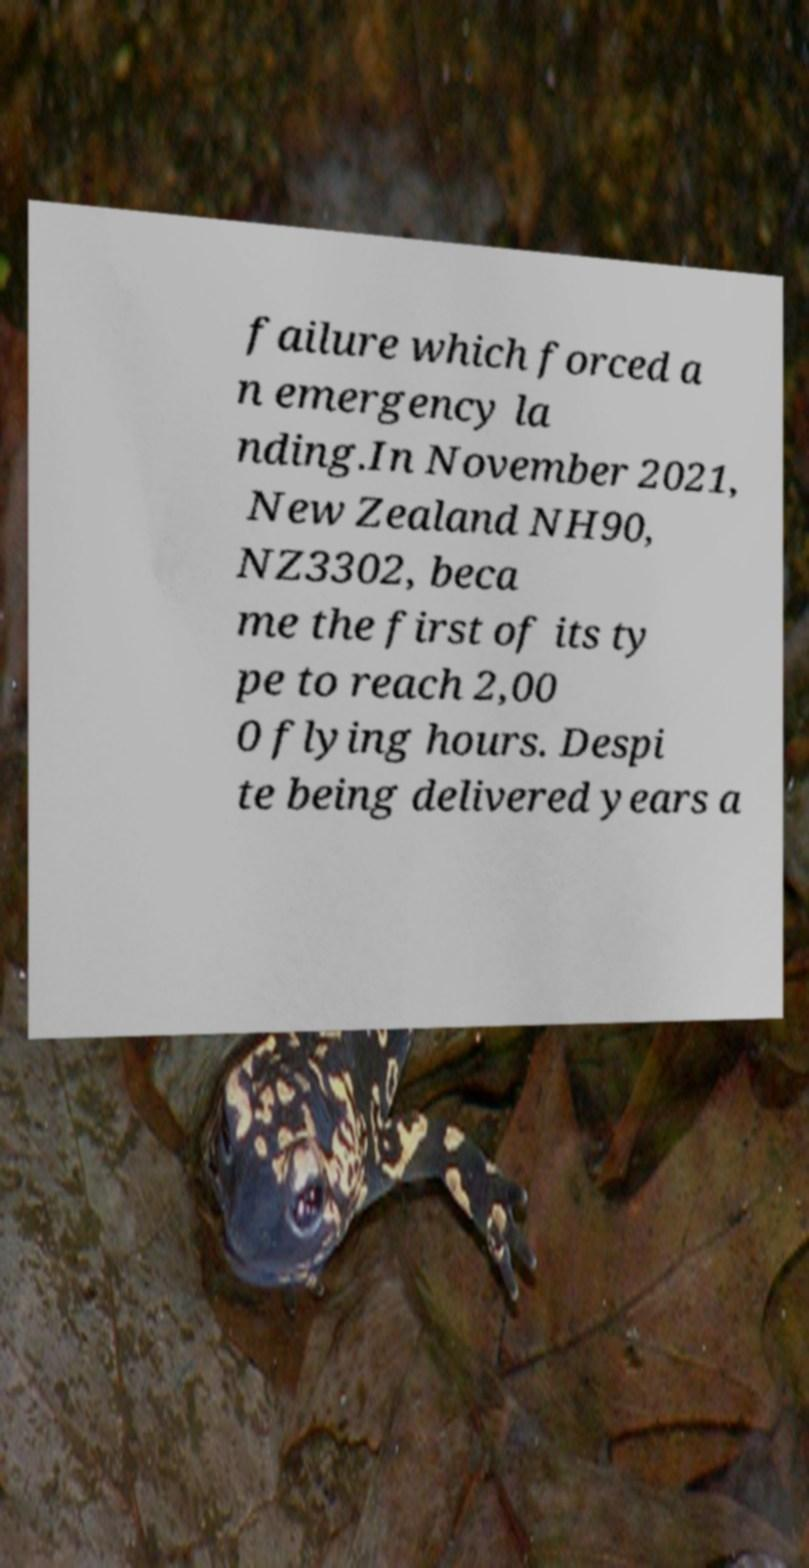Please identify and transcribe the text found in this image. failure which forced a n emergency la nding.In November 2021, New Zealand NH90, NZ3302, beca me the first of its ty pe to reach 2,00 0 flying hours. Despi te being delivered years a 